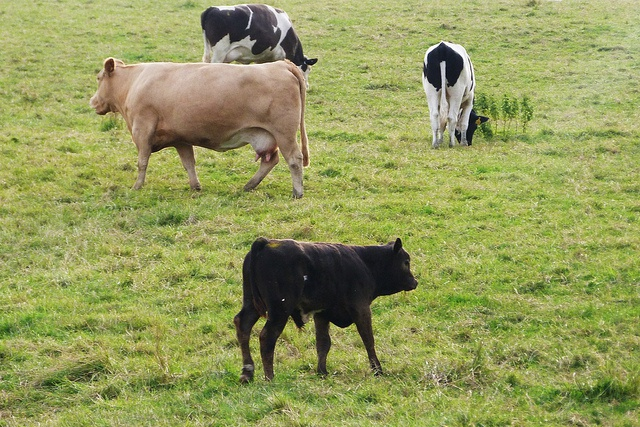Describe the objects in this image and their specific colors. I can see cow in khaki, gray, and tan tones, cow in khaki, black, gray, and darkgreen tones, cow in khaki, black, darkgray, gray, and lightgray tones, and cow in khaki, black, lightgray, darkgray, and gray tones in this image. 